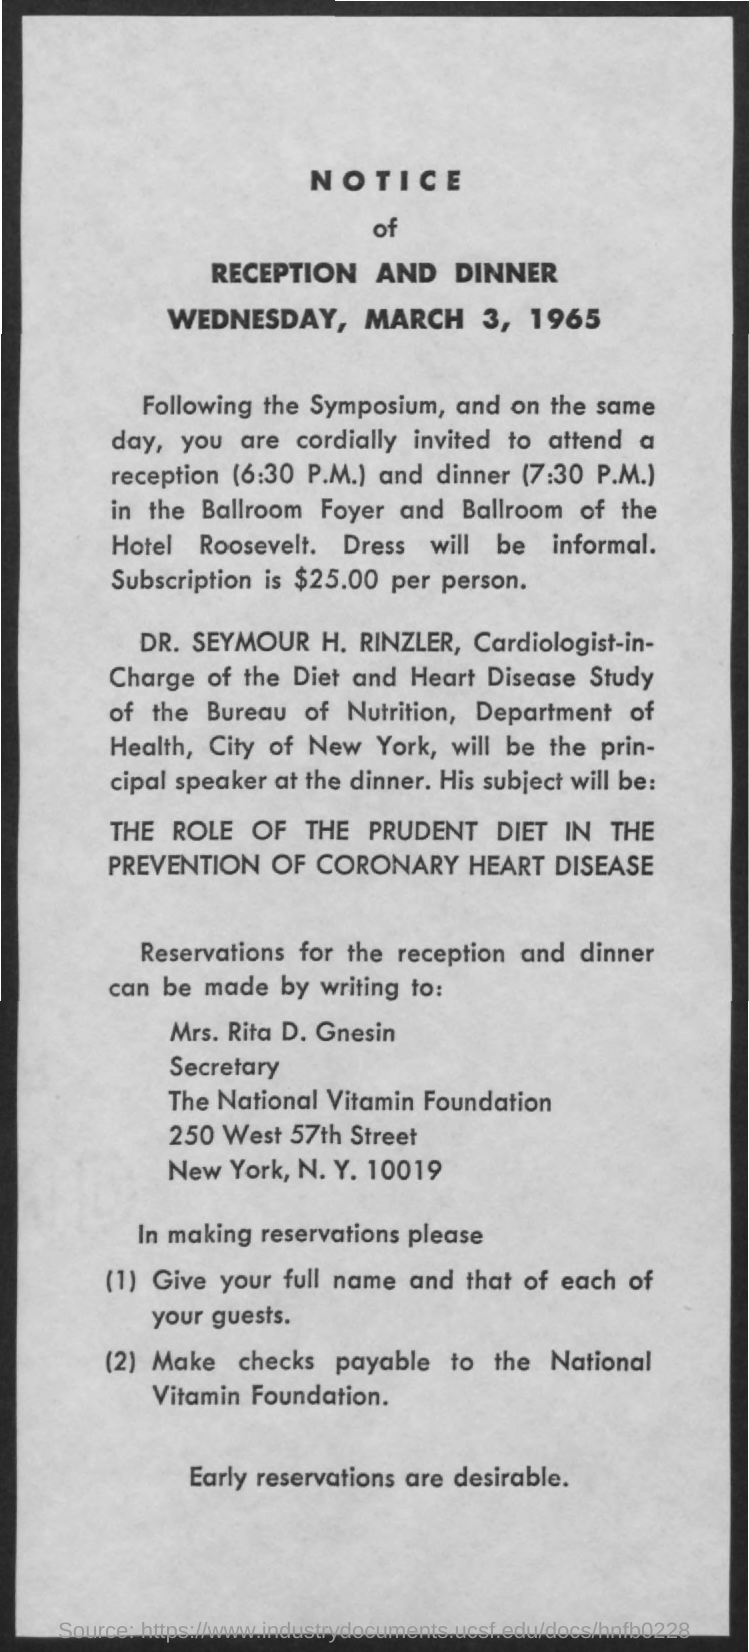When is the reception and dinner?
Your answer should be compact. Wednesday, March 3, 1965. What is the cost of Subscription?
Your answer should be very brief. $25.00. What time is the reception?
Provide a succinct answer. 6:30 P.M. What time is the Dinner?
Ensure brevity in your answer.  7:30 P.M. Who is the Cardiologist-in-Charge of the diet and heart disease study of bureau of nutrition?
Ensure brevity in your answer.  Dr. Seymour H. Rinzler. Role of what in the prevention of coronary heart disease?
Your response must be concise. The Prudent diet. Reservations for the reception and dinner can be made by writing to whom?
Make the answer very short. Mrs. Rita D. Gnesin. Make checks payable to whom?
Make the answer very short. NATIONAL VITAMIN FOUNDATION. 